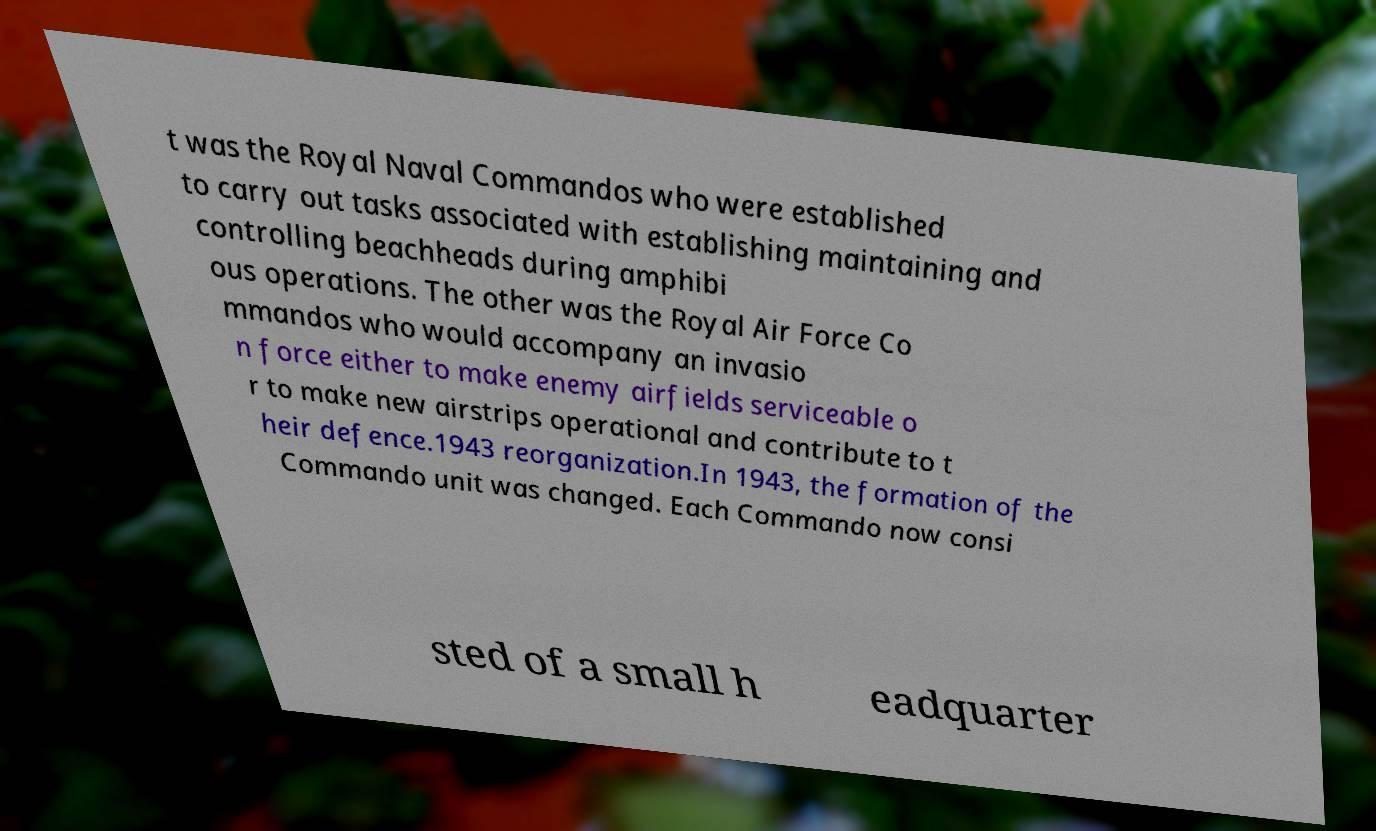Can you read and provide the text displayed in the image?This photo seems to have some interesting text. Can you extract and type it out for me? t was the Royal Naval Commandos who were established to carry out tasks associated with establishing maintaining and controlling beachheads during amphibi ous operations. The other was the Royal Air Force Co mmandos who would accompany an invasio n force either to make enemy airfields serviceable o r to make new airstrips operational and contribute to t heir defence.1943 reorganization.In 1943, the formation of the Commando unit was changed. Each Commando now consi sted of a small h eadquarter 